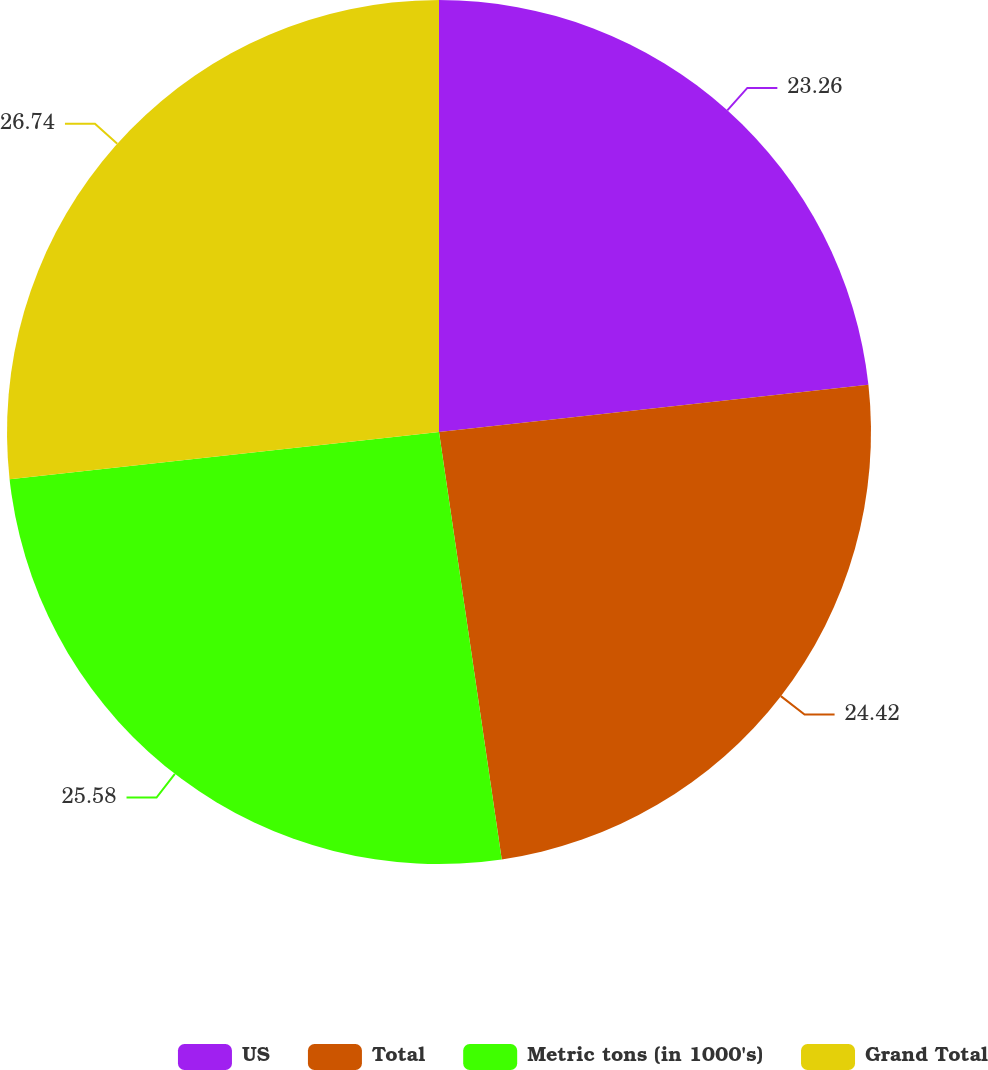<chart> <loc_0><loc_0><loc_500><loc_500><pie_chart><fcel>US<fcel>Total<fcel>Metric tons (in 1000's)<fcel>Grand Total<nl><fcel>23.26%<fcel>24.42%<fcel>25.58%<fcel>26.74%<nl></chart> 